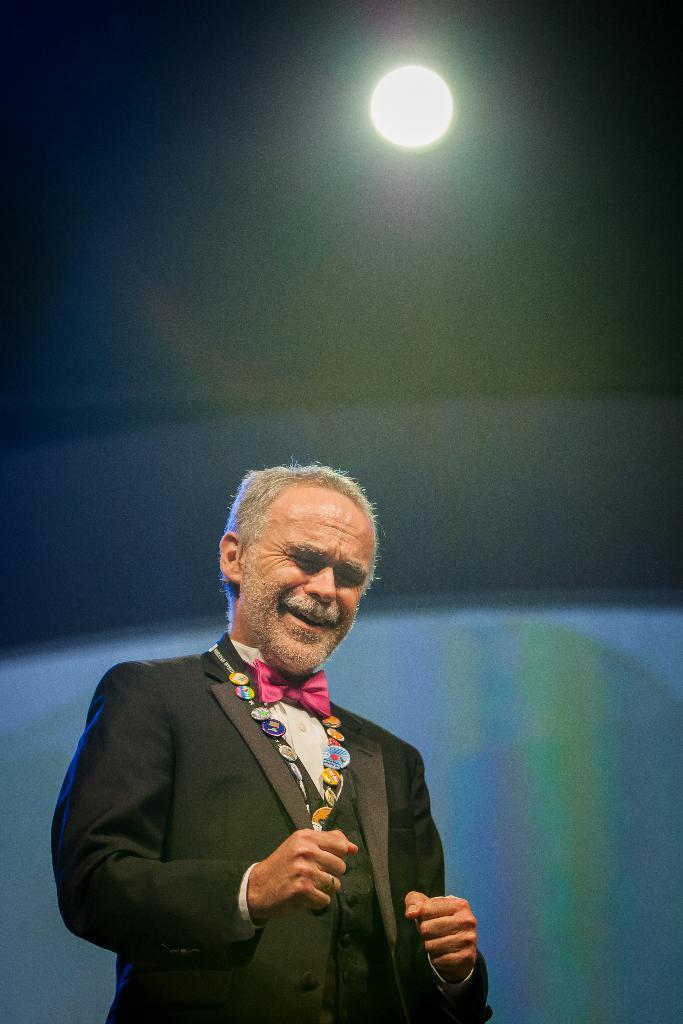Could you give a brief overview of what you see in this image? Here we can see a man and on the roof top there is a light. In the background there is an object. 